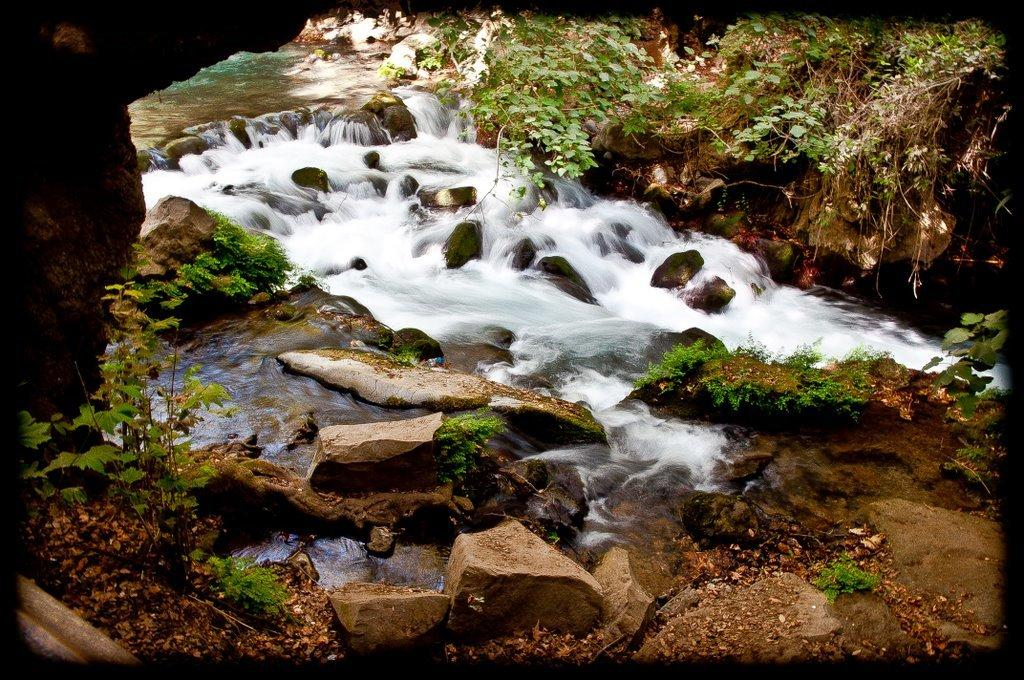What type of natural environment is depicted in the image? The image features grass, water, plants, and rocks, which suggests a natural environment. Can you describe the water in the image? The image contains water, but it doesn't provide specific details about the water. What other natural elements are present in the image? Besides grass, water, and plants, there are also rocks in the image. Can you see a veil covering the plants in the image? There is no veil present in the image; it only features grass, water, plants, and rocks. What type of bait is being used to catch fish in the water? There is no fishing activity depicted in the image, so it's not possible to determine what type of bait might be used. 